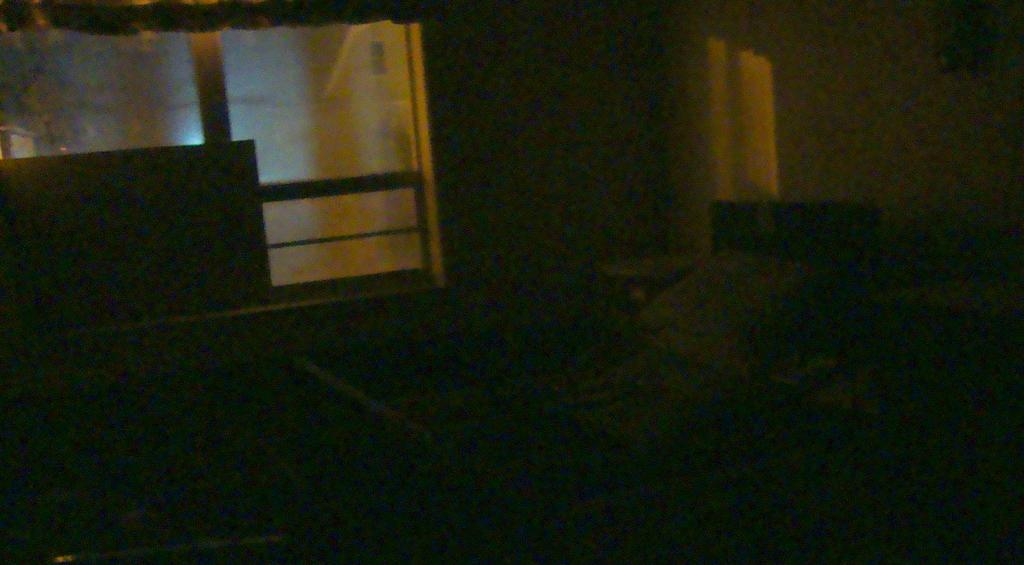What is the lighting condition in the foreground of the image? The foreground of the image is dark. What can be seen on the wall in the background of the image? There are glass windows on a wall in the background. What is visible through the windows in the image? There is a building visible behind the windows. What time of day is it in the image, given the presence of ducks? There are no ducks present in the image, so it is not possible to determine the time of day based on their presence. 